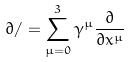Convert formula to latex. <formula><loc_0><loc_0><loc_500><loc_500>\partial / = \sum _ { \mu = 0 } ^ { 3 } \gamma ^ { \mu } \frac { \partial } { \partial x ^ { \mu } }</formula> 